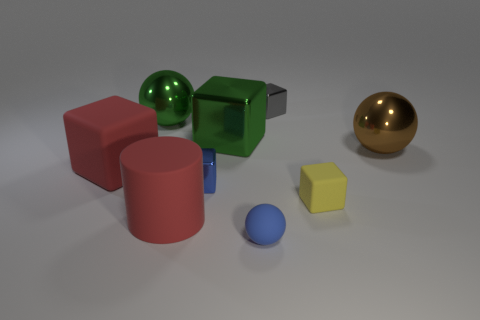Add 1 big blue cylinders. How many objects exist? 10 Subtract all gray metallic cubes. How many cubes are left? 4 Subtract all blue balls. How many balls are left? 2 Subtract 1 spheres. How many spheres are left? 2 Subtract all green shiny balls. Subtract all large brown things. How many objects are left? 7 Add 1 red things. How many red things are left? 3 Add 8 large green metal balls. How many large green metal balls exist? 9 Subtract 1 green balls. How many objects are left? 8 Subtract all cylinders. How many objects are left? 8 Subtract all cyan cubes. Subtract all gray cylinders. How many cubes are left? 5 